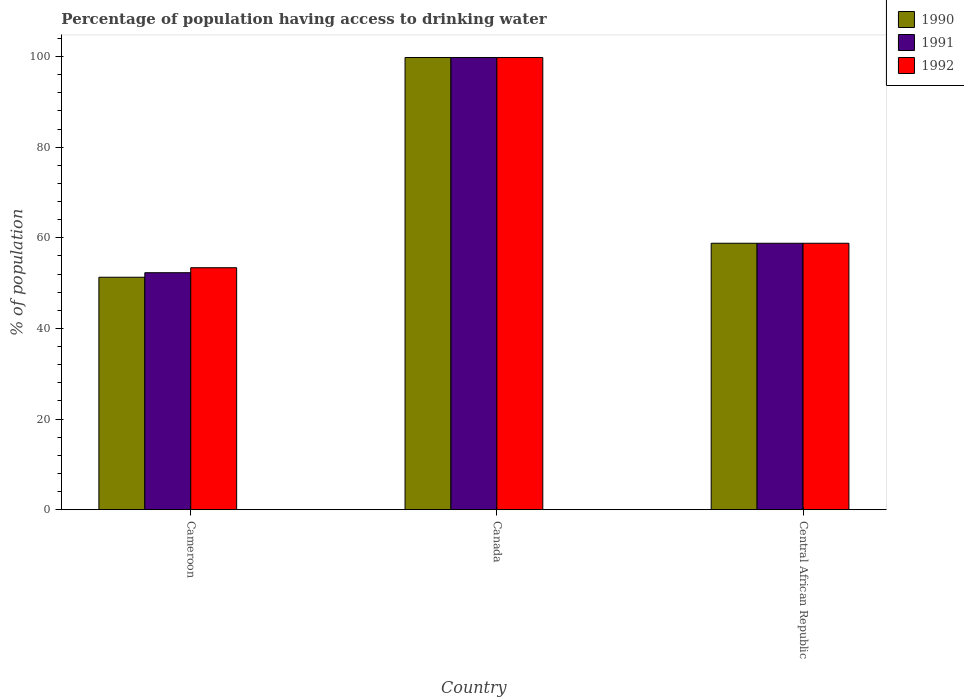How many bars are there on the 1st tick from the left?
Provide a succinct answer. 3. How many bars are there on the 1st tick from the right?
Ensure brevity in your answer.  3. What is the label of the 1st group of bars from the left?
Keep it short and to the point. Cameroon. What is the percentage of population having access to drinking water in 1990 in Cameroon?
Ensure brevity in your answer.  51.3. Across all countries, what is the maximum percentage of population having access to drinking water in 1992?
Your answer should be very brief. 99.8. Across all countries, what is the minimum percentage of population having access to drinking water in 1992?
Offer a terse response. 53.4. In which country was the percentage of population having access to drinking water in 1991 minimum?
Provide a short and direct response. Cameroon. What is the total percentage of population having access to drinking water in 1992 in the graph?
Keep it short and to the point. 212. What is the difference between the percentage of population having access to drinking water in 1992 in Canada and the percentage of population having access to drinking water in 1990 in Central African Republic?
Offer a terse response. 41. What is the average percentage of population having access to drinking water in 1992 per country?
Give a very brief answer. 70.67. What is the ratio of the percentage of population having access to drinking water in 1990 in Canada to that in Central African Republic?
Keep it short and to the point. 1.7. What is the difference between the highest and the lowest percentage of population having access to drinking water in 1992?
Provide a succinct answer. 46.4. Is the sum of the percentage of population having access to drinking water in 1990 in Cameroon and Canada greater than the maximum percentage of population having access to drinking water in 1992 across all countries?
Make the answer very short. Yes. What does the 2nd bar from the left in Cameroon represents?
Your answer should be compact. 1991. Is it the case that in every country, the sum of the percentage of population having access to drinking water in 1991 and percentage of population having access to drinking water in 1990 is greater than the percentage of population having access to drinking water in 1992?
Make the answer very short. Yes. How many countries are there in the graph?
Offer a very short reply. 3. What is the difference between two consecutive major ticks on the Y-axis?
Ensure brevity in your answer.  20. Are the values on the major ticks of Y-axis written in scientific E-notation?
Keep it short and to the point. No. Does the graph contain grids?
Offer a very short reply. No. Where does the legend appear in the graph?
Your answer should be compact. Top right. How are the legend labels stacked?
Provide a succinct answer. Vertical. What is the title of the graph?
Ensure brevity in your answer.  Percentage of population having access to drinking water. What is the label or title of the Y-axis?
Your answer should be compact. % of population. What is the % of population of 1990 in Cameroon?
Provide a short and direct response. 51.3. What is the % of population of 1991 in Cameroon?
Offer a terse response. 52.3. What is the % of population in 1992 in Cameroon?
Your response must be concise. 53.4. What is the % of population of 1990 in Canada?
Make the answer very short. 99.8. What is the % of population of 1991 in Canada?
Provide a short and direct response. 99.8. What is the % of population in 1992 in Canada?
Your response must be concise. 99.8. What is the % of population of 1990 in Central African Republic?
Provide a succinct answer. 58.8. What is the % of population of 1991 in Central African Republic?
Provide a succinct answer. 58.8. What is the % of population in 1992 in Central African Republic?
Ensure brevity in your answer.  58.8. Across all countries, what is the maximum % of population of 1990?
Your response must be concise. 99.8. Across all countries, what is the maximum % of population in 1991?
Ensure brevity in your answer.  99.8. Across all countries, what is the maximum % of population of 1992?
Offer a very short reply. 99.8. Across all countries, what is the minimum % of population of 1990?
Your answer should be very brief. 51.3. Across all countries, what is the minimum % of population in 1991?
Ensure brevity in your answer.  52.3. Across all countries, what is the minimum % of population in 1992?
Make the answer very short. 53.4. What is the total % of population of 1990 in the graph?
Make the answer very short. 209.9. What is the total % of population in 1991 in the graph?
Offer a terse response. 210.9. What is the total % of population in 1992 in the graph?
Offer a very short reply. 212. What is the difference between the % of population in 1990 in Cameroon and that in Canada?
Ensure brevity in your answer.  -48.5. What is the difference between the % of population of 1991 in Cameroon and that in Canada?
Offer a very short reply. -47.5. What is the difference between the % of population in 1992 in Cameroon and that in Canada?
Your response must be concise. -46.4. What is the difference between the % of population in 1990 in Cameroon and that in Central African Republic?
Offer a very short reply. -7.5. What is the difference between the % of population of 1991 in Cameroon and that in Central African Republic?
Provide a short and direct response. -6.5. What is the difference between the % of population in 1992 in Cameroon and that in Central African Republic?
Make the answer very short. -5.4. What is the difference between the % of population of 1990 in Canada and that in Central African Republic?
Make the answer very short. 41. What is the difference between the % of population in 1990 in Cameroon and the % of population in 1991 in Canada?
Give a very brief answer. -48.5. What is the difference between the % of population of 1990 in Cameroon and the % of population of 1992 in Canada?
Your answer should be compact. -48.5. What is the difference between the % of population in 1991 in Cameroon and the % of population in 1992 in Canada?
Provide a short and direct response. -47.5. What is the difference between the % of population in 1990 in Cameroon and the % of population in 1991 in Central African Republic?
Ensure brevity in your answer.  -7.5. What is the difference between the % of population of 1990 in Cameroon and the % of population of 1992 in Central African Republic?
Your response must be concise. -7.5. What is the difference between the % of population in 1991 in Cameroon and the % of population in 1992 in Central African Republic?
Provide a succinct answer. -6.5. What is the difference between the % of population in 1990 in Canada and the % of population in 1991 in Central African Republic?
Offer a terse response. 41. What is the average % of population of 1990 per country?
Your response must be concise. 69.97. What is the average % of population of 1991 per country?
Offer a terse response. 70.3. What is the average % of population in 1992 per country?
Give a very brief answer. 70.67. What is the difference between the % of population of 1990 and % of population of 1991 in Cameroon?
Offer a terse response. -1. What is the difference between the % of population of 1991 and % of population of 1992 in Canada?
Provide a short and direct response. 0. What is the difference between the % of population of 1990 and % of population of 1991 in Central African Republic?
Offer a very short reply. 0. What is the difference between the % of population in 1990 and % of population in 1992 in Central African Republic?
Offer a terse response. 0. What is the difference between the % of population in 1991 and % of population in 1992 in Central African Republic?
Offer a terse response. 0. What is the ratio of the % of population of 1990 in Cameroon to that in Canada?
Your answer should be very brief. 0.51. What is the ratio of the % of population of 1991 in Cameroon to that in Canada?
Your answer should be compact. 0.52. What is the ratio of the % of population in 1992 in Cameroon to that in Canada?
Provide a short and direct response. 0.54. What is the ratio of the % of population in 1990 in Cameroon to that in Central African Republic?
Keep it short and to the point. 0.87. What is the ratio of the % of population in 1991 in Cameroon to that in Central African Republic?
Provide a succinct answer. 0.89. What is the ratio of the % of population of 1992 in Cameroon to that in Central African Republic?
Your answer should be compact. 0.91. What is the ratio of the % of population in 1990 in Canada to that in Central African Republic?
Your answer should be compact. 1.7. What is the ratio of the % of population in 1991 in Canada to that in Central African Republic?
Keep it short and to the point. 1.7. What is the ratio of the % of population of 1992 in Canada to that in Central African Republic?
Ensure brevity in your answer.  1.7. What is the difference between the highest and the second highest % of population of 1992?
Provide a succinct answer. 41. What is the difference between the highest and the lowest % of population of 1990?
Offer a very short reply. 48.5. What is the difference between the highest and the lowest % of population in 1991?
Offer a very short reply. 47.5. What is the difference between the highest and the lowest % of population of 1992?
Offer a very short reply. 46.4. 